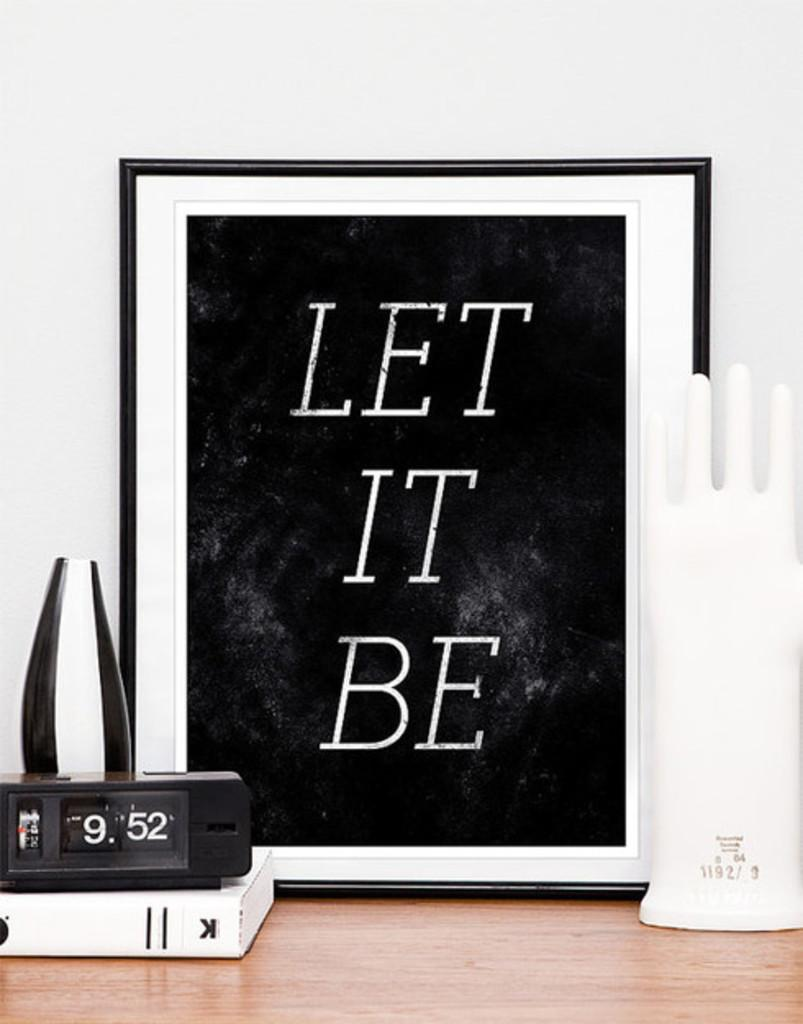<image>
Render a clear and concise summary of the photo. A framed sign says Let It Be and is set behind a clock that shows the time as 9:52. 